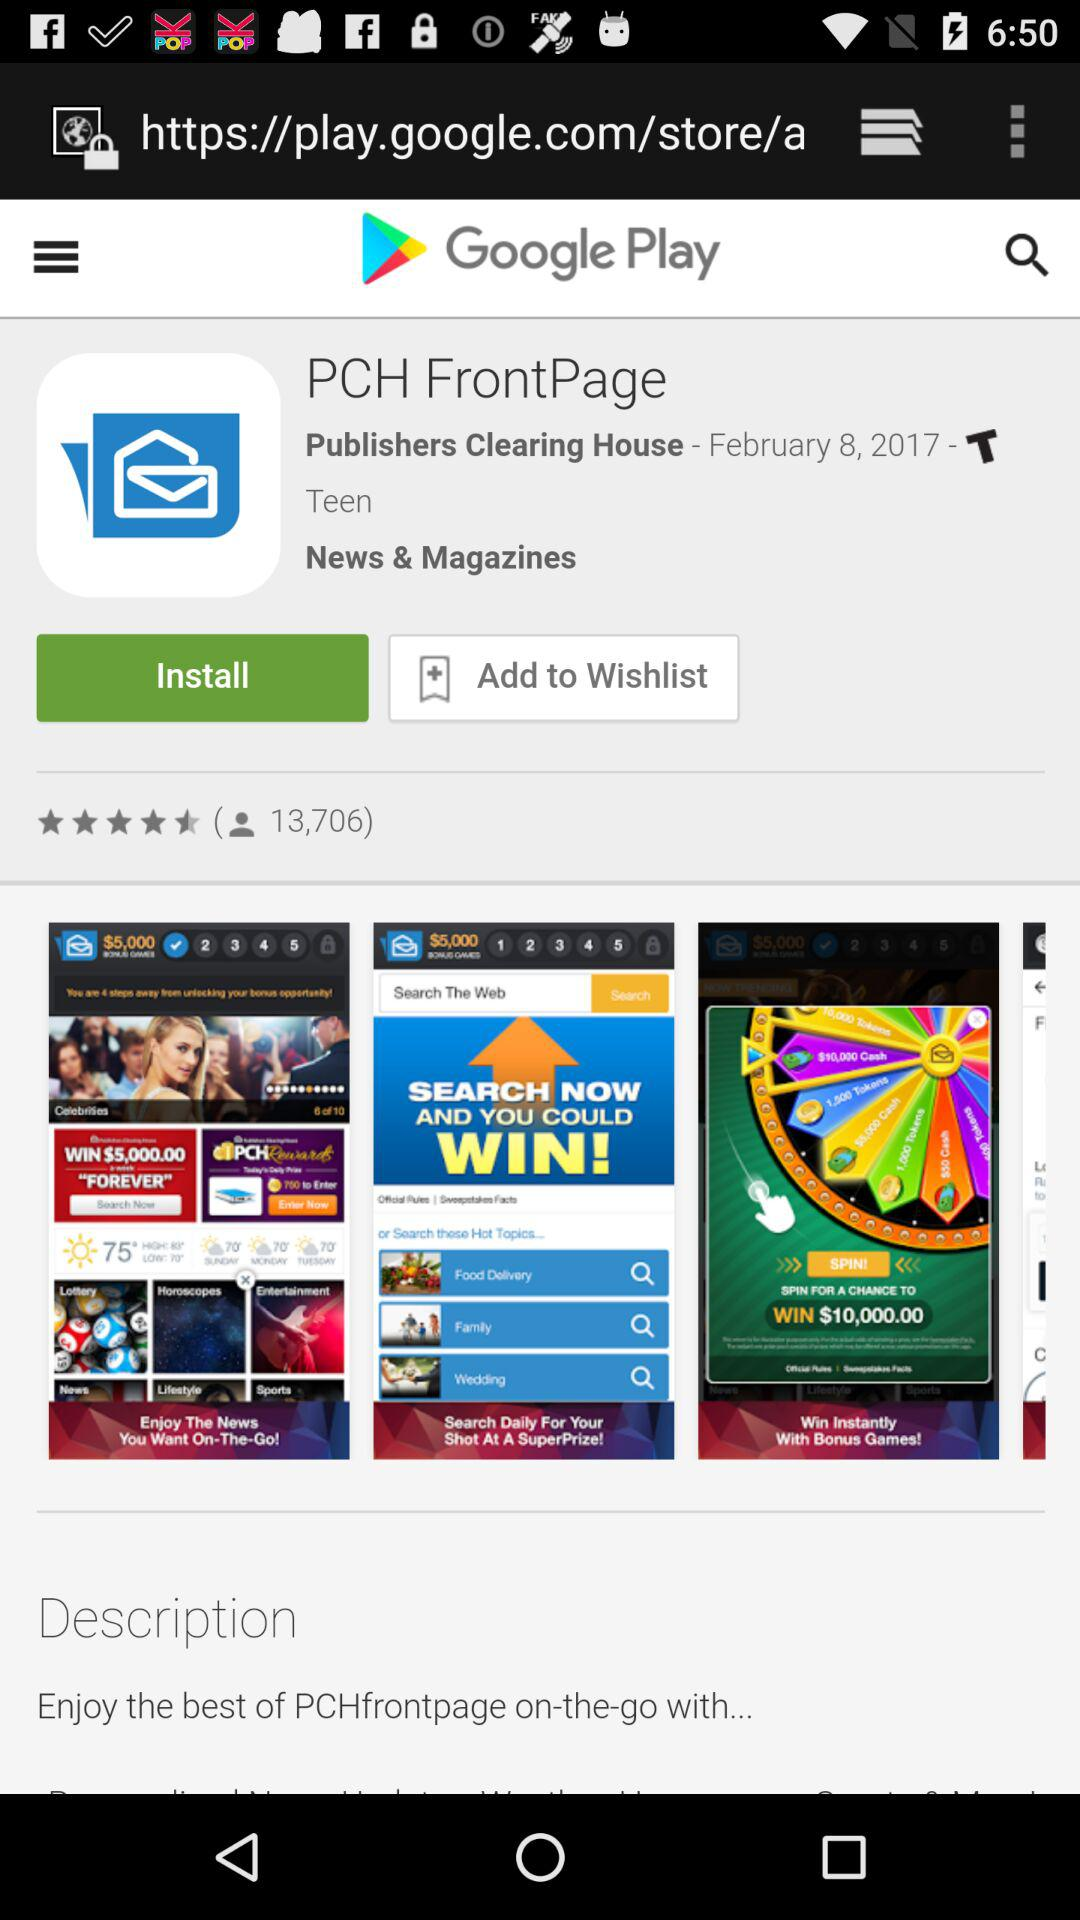What is the mentioned date? The mentioned date is February 8, 2017. 